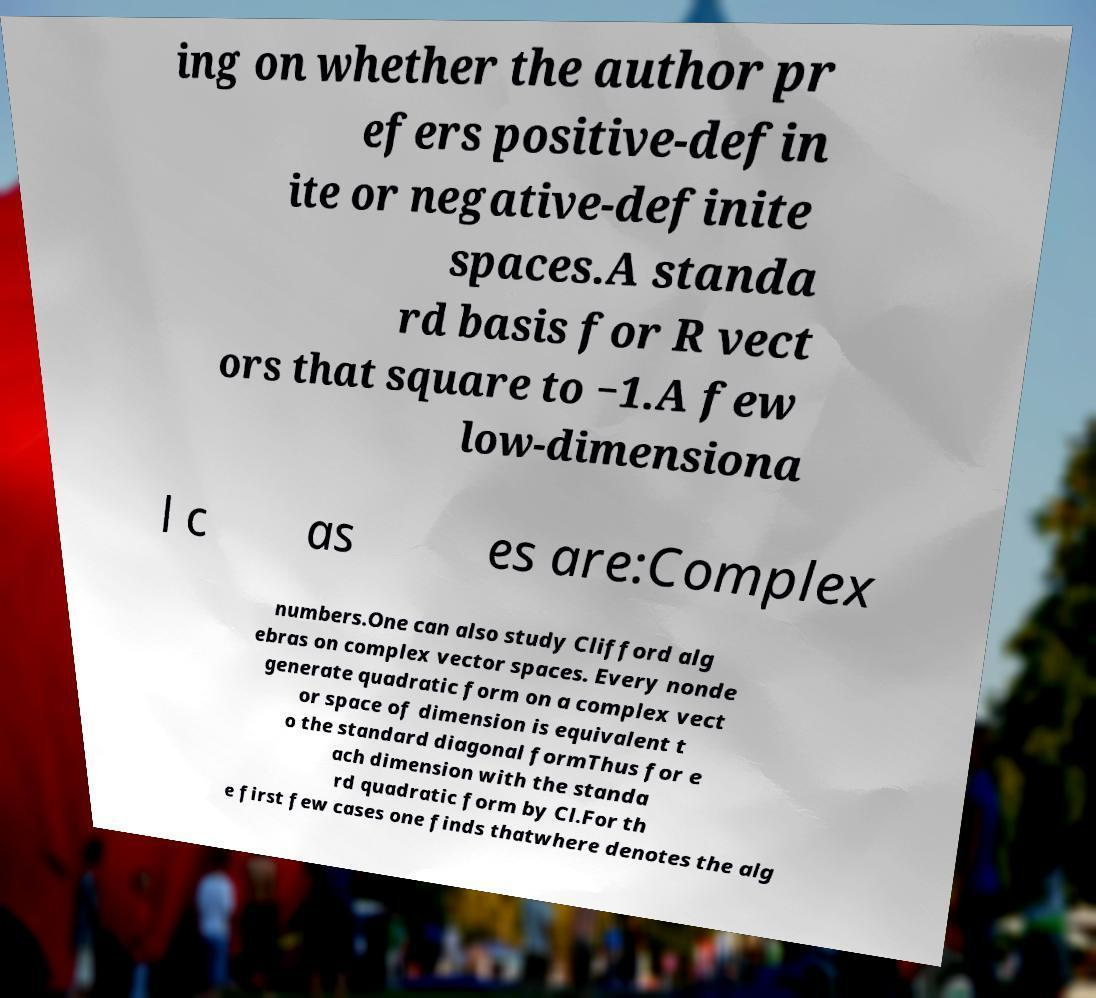Could you assist in decoding the text presented in this image and type it out clearly? ing on whether the author pr efers positive-defin ite or negative-definite spaces.A standa rd basis for R vect ors that square to −1.A few low-dimensiona l c as es are:Complex numbers.One can also study Clifford alg ebras on complex vector spaces. Every nonde generate quadratic form on a complex vect or space of dimension is equivalent t o the standard diagonal formThus for e ach dimension with the standa rd quadratic form by Cl.For th e first few cases one finds thatwhere denotes the alg 